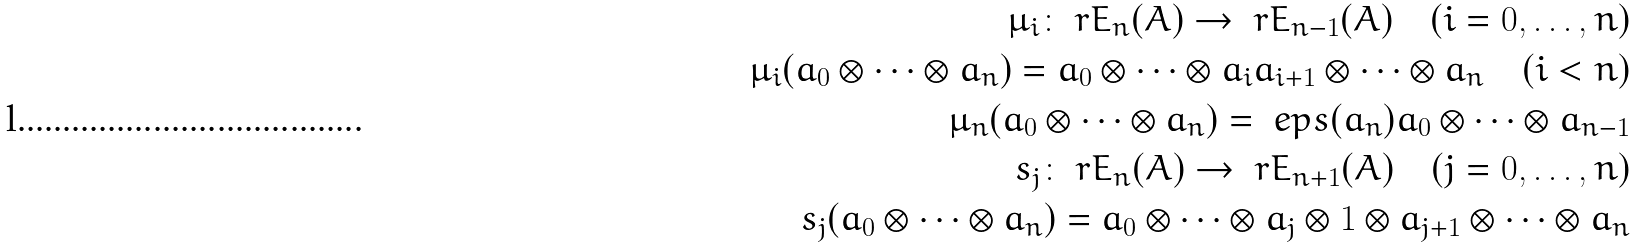<formula> <loc_0><loc_0><loc_500><loc_500>\mu _ { i } \colon \ r E _ { n } ( A ) \to \ r E _ { n - 1 } ( A ) \quad ( i = 0 , \dots , n ) \\ \mu _ { i } ( a _ { 0 } \otimes \dots \otimes a _ { n } ) = a _ { 0 } \otimes \dots \otimes a _ { i } a _ { i + 1 } \otimes \dots \otimes a _ { n } \quad ( i < n ) \\ \mu _ { n } ( a _ { 0 } \otimes \dots \otimes a _ { n } ) = \ e p s ( a _ { n } ) a _ { 0 } \otimes \dots \otimes a _ { n - 1 } \\ s _ { j } \colon \ r E _ { n } ( A ) \to \ r E _ { n + 1 } ( A ) \quad ( j = 0 , \dots , n ) \\ s _ { j } ( a _ { 0 } \otimes \dots \otimes a _ { n } ) = a _ { 0 } \otimes \dots \otimes a _ { j } \otimes 1 \otimes a _ { j + 1 } \otimes \dots \otimes a _ { n }</formula> 